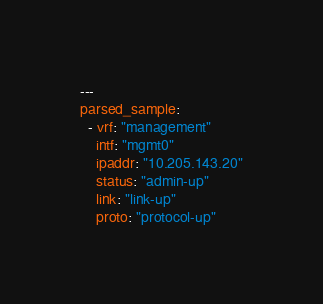<code> <loc_0><loc_0><loc_500><loc_500><_YAML_>---
parsed_sample:
  - vrf: "management"
    intf: "mgmt0"
    ipaddr: "10.205.143.20"
    status: "admin-up"
    link: "link-up"
    proto: "protocol-up"
</code> 